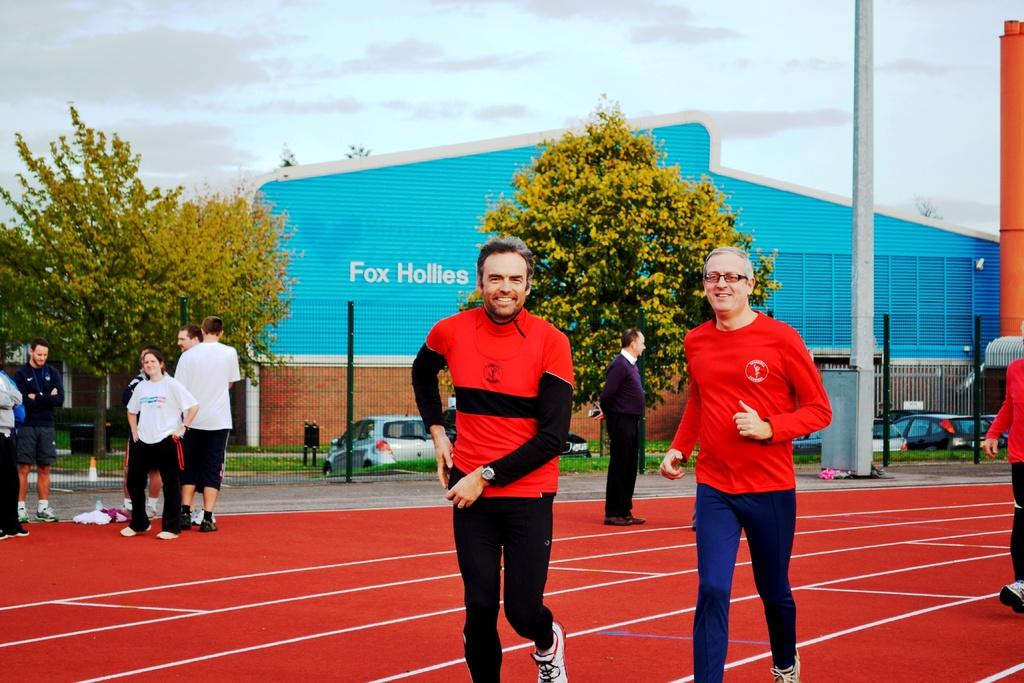Who or what can be seen in the image? There are people in the image. What can be seen in the distance behind the people? There is a shed, boards, vehicles, trees, and grass visible in the background. Can you see a hose at the seashore in the image? There is no hose or seashore present in the image. Is there a market visible in the background of the image? There is no market visible in the image; only a shed, boards, vehicles, trees, and grass are present in the background. 